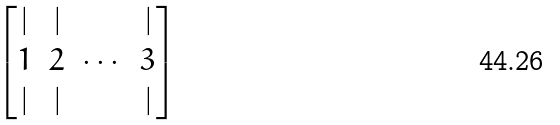Convert formula to latex. <formula><loc_0><loc_0><loc_500><loc_500>\begin{bmatrix} | & | & & | \\ { 1 } & { 2 } & \cdots & { 3 } \\ | & | & & | \end{bmatrix}</formula> 